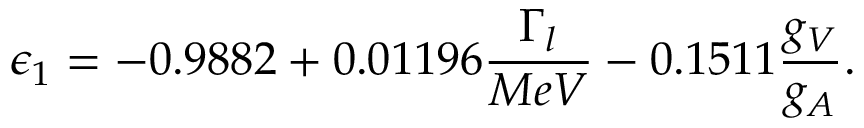<formula> <loc_0><loc_0><loc_500><loc_500>\epsilon _ { 1 } = - 0 . 9 8 8 2 + 0 . 0 1 1 9 6 \frac { \Gamma _ { l } } { M e V } - 0 . 1 5 1 1 \frac { g _ { V } } { g _ { A } } .</formula> 